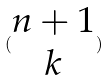Convert formula to latex. <formula><loc_0><loc_0><loc_500><loc_500>( \begin{matrix} n + 1 \\ k \end{matrix} )</formula> 